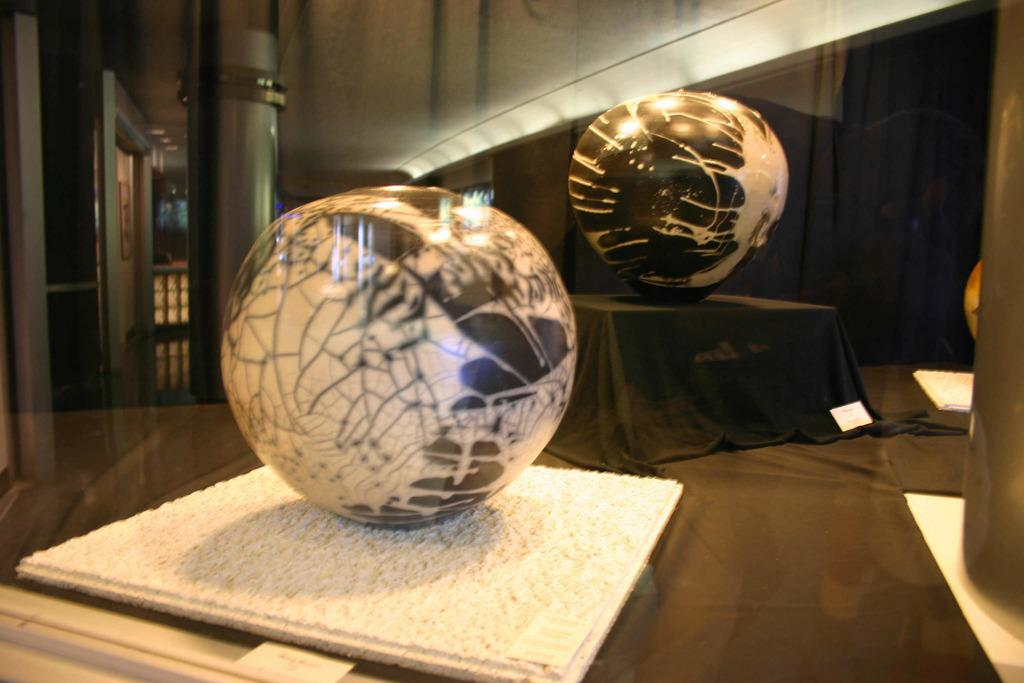What is located at the bottom of the image? There is a table at the bottom of the image. What can be seen on the table? There are decorations, a cloth, and a box on the table. What is visible in the background of the image? There is a pillar, a door, and a wall in the background of the image. What type of plastic material can be seen on the table? There is no plastic material visible on the table in the image. Can you see a pencil being used by someone in the image? There is no pencil or anyone using a pencil in the image. 